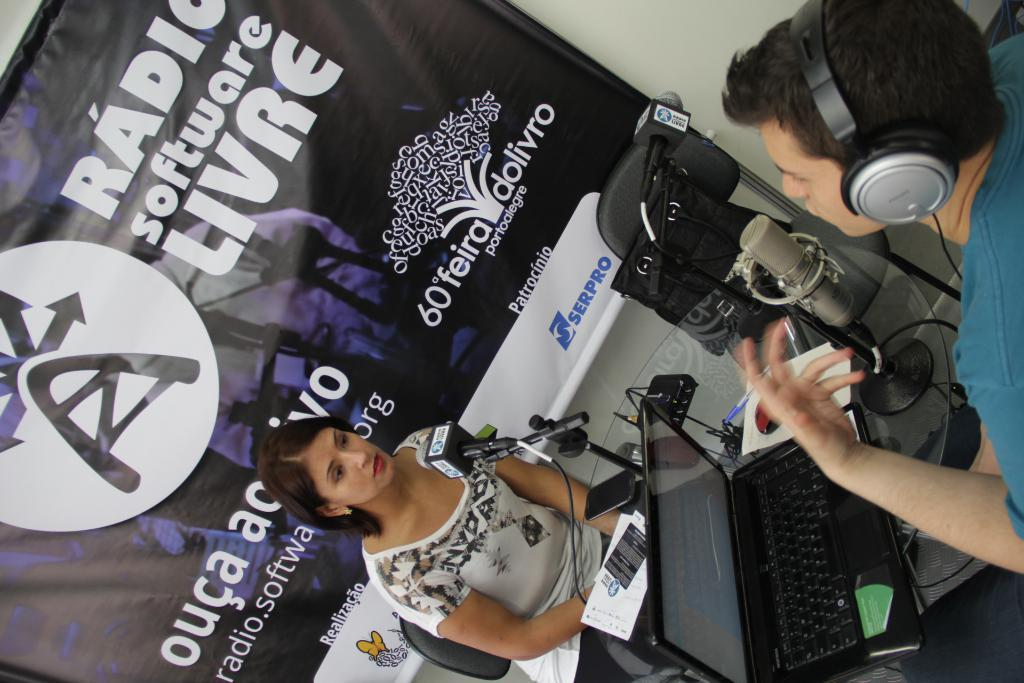<image>
Summarize the visual content of the image. A radio interview is taking place in front of a sign that says radio software livre. 